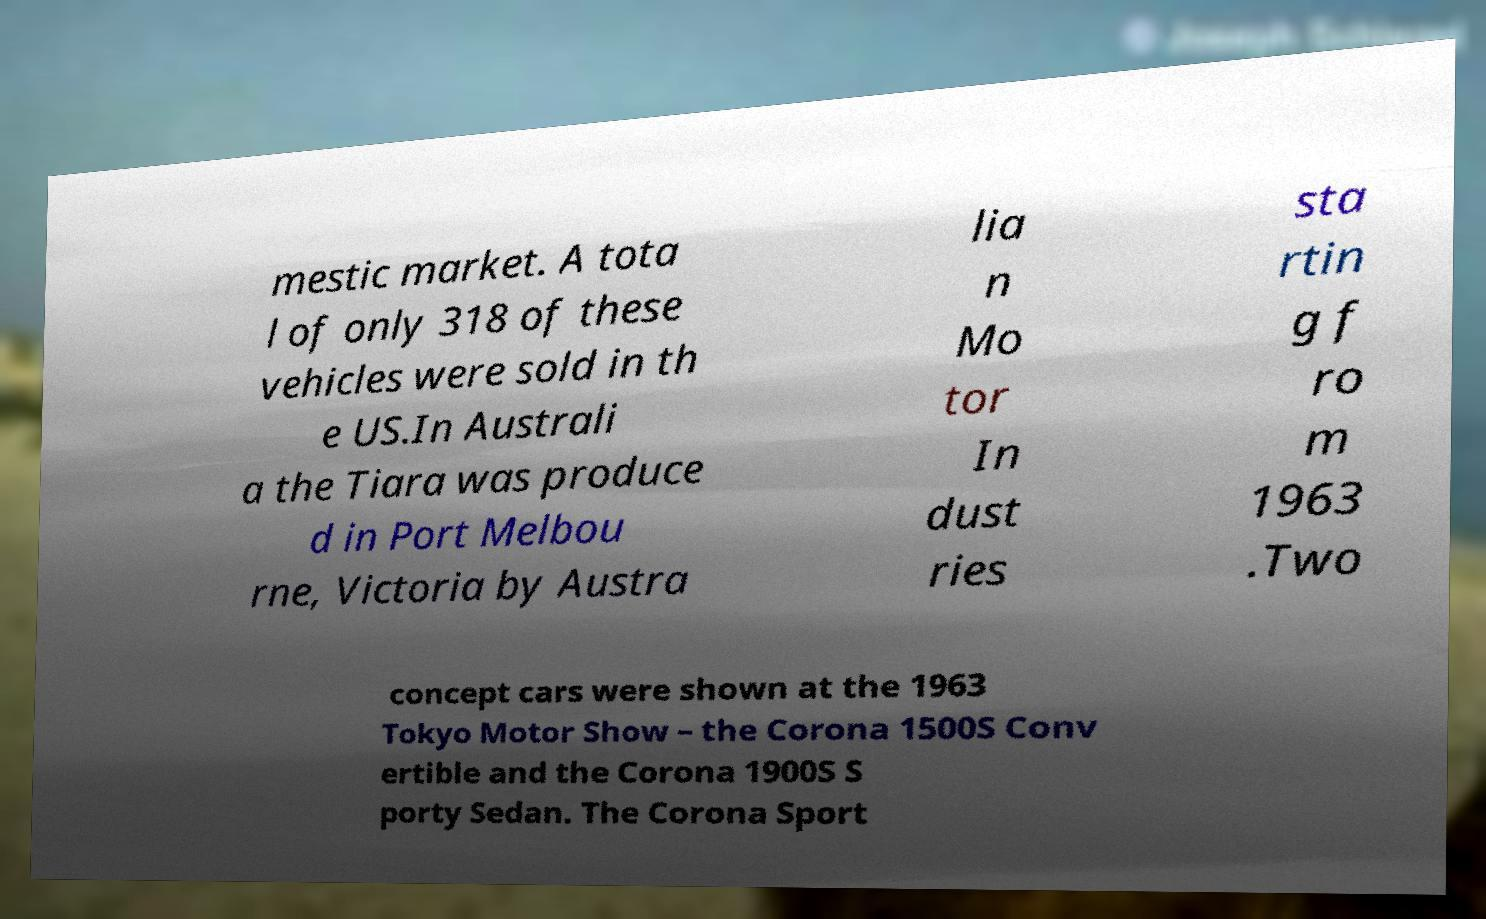What messages or text are displayed in this image? I need them in a readable, typed format. mestic market. A tota l of only 318 of these vehicles were sold in th e US.In Australi a the Tiara was produce d in Port Melbou rne, Victoria by Austra lia n Mo tor In dust ries sta rtin g f ro m 1963 .Two concept cars were shown at the 1963 Tokyo Motor Show – the Corona 1500S Conv ertible and the Corona 1900S S porty Sedan. The Corona Sport 